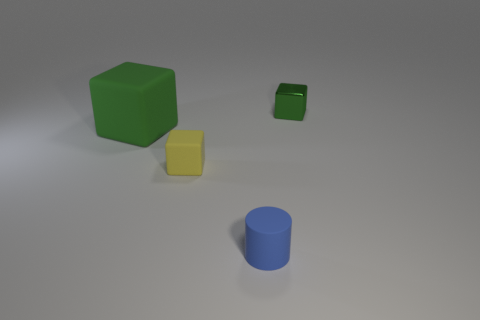Do the small matte thing behind the tiny cylinder and the tiny green shiny thing have the same shape?
Offer a terse response. Yes. Are there any other things that are the same material as the yellow thing?
Your response must be concise. Yes. What number of things are small green matte things or green things left of the yellow thing?
Ensure brevity in your answer.  1. What size is the cube that is both on the right side of the large cube and to the left of the small green block?
Keep it short and to the point. Small. Are there more blue cylinders that are in front of the big matte block than blue rubber cylinders on the right side of the tiny green object?
Offer a very short reply. Yes. There is a tiny yellow thing; is its shape the same as the object behind the big green matte block?
Give a very brief answer. Yes. What number of other things are the same shape as the green shiny object?
Ensure brevity in your answer.  2. What is the color of the cube that is right of the large green object and left of the shiny cube?
Your response must be concise. Yellow. The tiny rubber cube is what color?
Give a very brief answer. Yellow. Is the small cylinder made of the same material as the tiny thing that is behind the yellow rubber block?
Provide a short and direct response. No. 